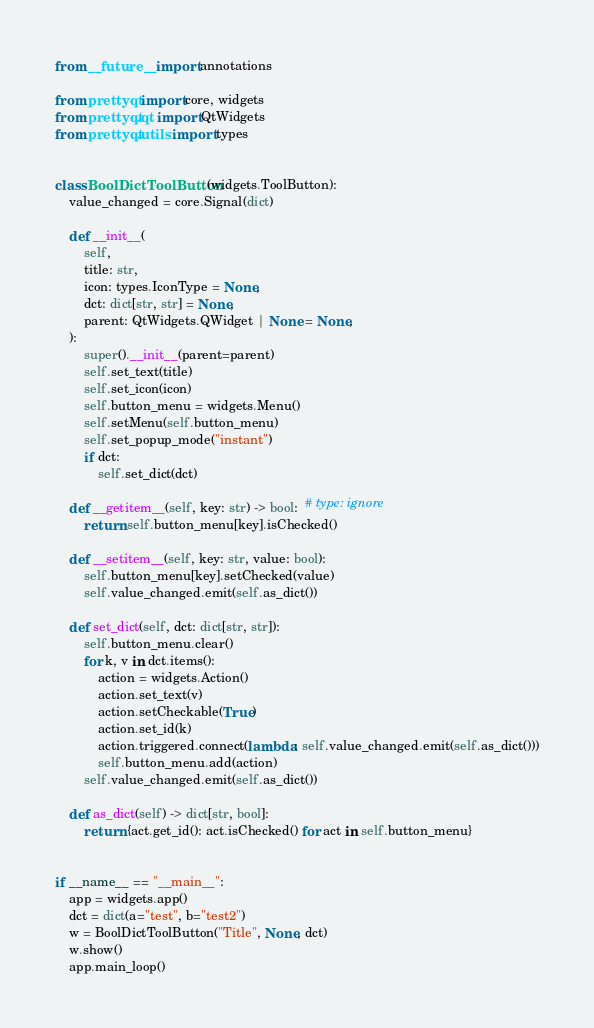Convert code to text. <code><loc_0><loc_0><loc_500><loc_500><_Python_>from __future__ import annotations

from prettyqt import core, widgets
from prettyqt.qt import QtWidgets
from prettyqt.utils import types


class BoolDictToolButton(widgets.ToolButton):
    value_changed = core.Signal(dict)

    def __init__(
        self,
        title: str,
        icon: types.IconType = None,
        dct: dict[str, str] = None,
        parent: QtWidgets.QWidget | None = None,
    ):
        super().__init__(parent=parent)
        self.set_text(title)
        self.set_icon(icon)
        self.button_menu = widgets.Menu()
        self.setMenu(self.button_menu)
        self.set_popup_mode("instant")
        if dct:
            self.set_dict(dct)

    def __getitem__(self, key: str) -> bool:  # type: ignore
        return self.button_menu[key].isChecked()

    def __setitem__(self, key: str, value: bool):
        self.button_menu[key].setChecked(value)
        self.value_changed.emit(self.as_dict())

    def set_dict(self, dct: dict[str, str]):
        self.button_menu.clear()
        for k, v in dct.items():
            action = widgets.Action()
            action.set_text(v)
            action.setCheckable(True)
            action.set_id(k)
            action.triggered.connect(lambda: self.value_changed.emit(self.as_dict()))
            self.button_menu.add(action)
        self.value_changed.emit(self.as_dict())

    def as_dict(self) -> dict[str, bool]:
        return {act.get_id(): act.isChecked() for act in self.button_menu}


if __name__ == "__main__":
    app = widgets.app()
    dct = dict(a="test", b="test2")
    w = BoolDictToolButton("Title", None, dct)
    w.show()
    app.main_loop()
</code> 